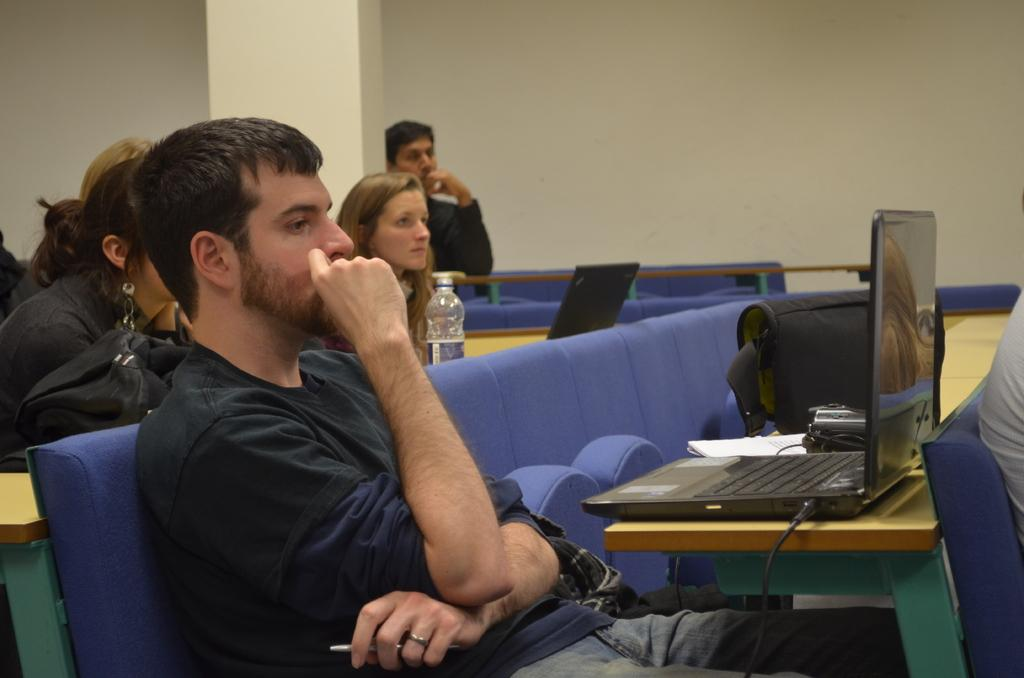How many people are in the image? There is a group of people in the image. What are the people doing in the image? The people are sitting in the image. What is in front of the people? The people are in front of a table. What items can be seen on the table? There is a bag and a laptop on the table. How many sisters are sitting together in the image? There is no mention of sisters in the image, so we cannot determine the number of sisters present. 